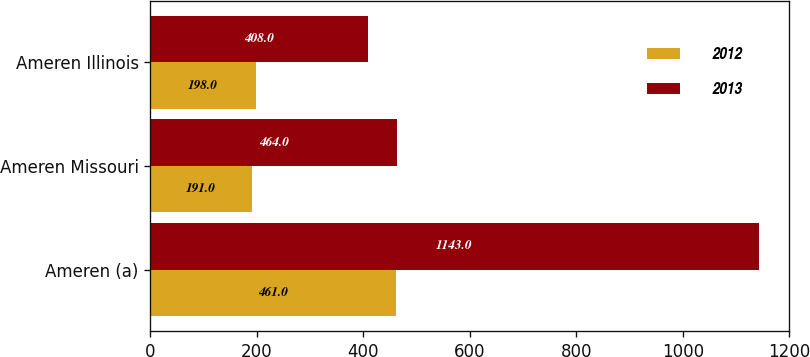<chart> <loc_0><loc_0><loc_500><loc_500><stacked_bar_chart><ecel><fcel>Ameren (a)<fcel>Ameren Missouri<fcel>Ameren Illinois<nl><fcel>2012<fcel>461<fcel>191<fcel>198<nl><fcel>2013<fcel>1143<fcel>464<fcel>408<nl></chart> 